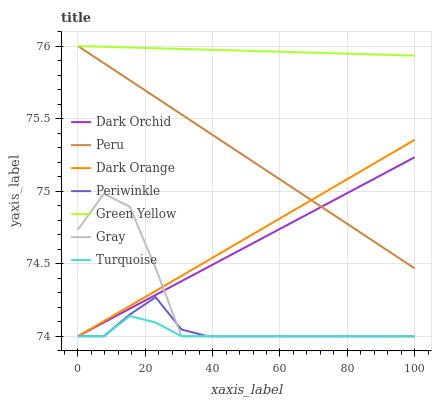Does Turquoise have the minimum area under the curve?
Answer yes or no. Yes. Does Green Yellow have the maximum area under the curve?
Answer yes or no. Yes. Does Gray have the minimum area under the curve?
Answer yes or no. No. Does Gray have the maximum area under the curve?
Answer yes or no. No. Is Dark Orchid the smoothest?
Answer yes or no. Yes. Is Gray the roughest?
Answer yes or no. Yes. Is Turquoise the smoothest?
Answer yes or no. No. Is Turquoise the roughest?
Answer yes or no. No. Does Dark Orange have the lowest value?
Answer yes or no. Yes. Does Peru have the lowest value?
Answer yes or no. No. Does Green Yellow have the highest value?
Answer yes or no. Yes. Does Gray have the highest value?
Answer yes or no. No. Is Dark Orchid less than Green Yellow?
Answer yes or no. Yes. Is Green Yellow greater than Turquoise?
Answer yes or no. Yes. Does Dark Orchid intersect Peru?
Answer yes or no. Yes. Is Dark Orchid less than Peru?
Answer yes or no. No. Is Dark Orchid greater than Peru?
Answer yes or no. No. Does Dark Orchid intersect Green Yellow?
Answer yes or no. No. 